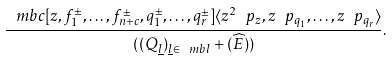Convert formula to latex. <formula><loc_0><loc_0><loc_500><loc_500>\frac { \ m b c [ z , f _ { 1 } ^ { \pm } , \dots , f _ { n + c } ^ { \pm } , q _ { 1 } ^ { \pm } , \dots , q _ { r } ^ { \pm } ] \langle z ^ { 2 } \ p _ { z } , z \ p _ { q _ { 1 } } , \dots , z \ p _ { q _ { r } } \rangle } { ( ( Q _ { \underline { l } } ) _ { \underline { l } \in \ m b l } + ( \widehat { E } ) ) } .</formula> 